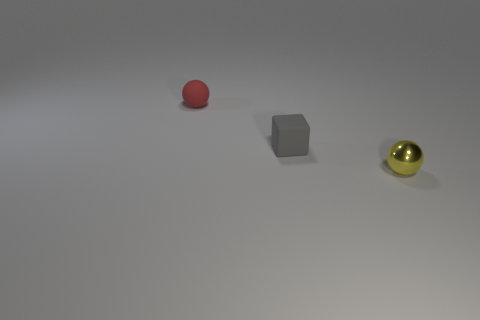Add 3 big yellow matte cylinders. How many objects exist? 6 Subtract all cubes. How many objects are left? 2 Add 1 small blue metallic spheres. How many small blue metallic spheres exist? 1 Subtract 0 purple spheres. How many objects are left? 3 Subtract all small blocks. Subtract all small matte blocks. How many objects are left? 1 Add 3 tiny gray rubber blocks. How many tiny gray rubber blocks are left? 4 